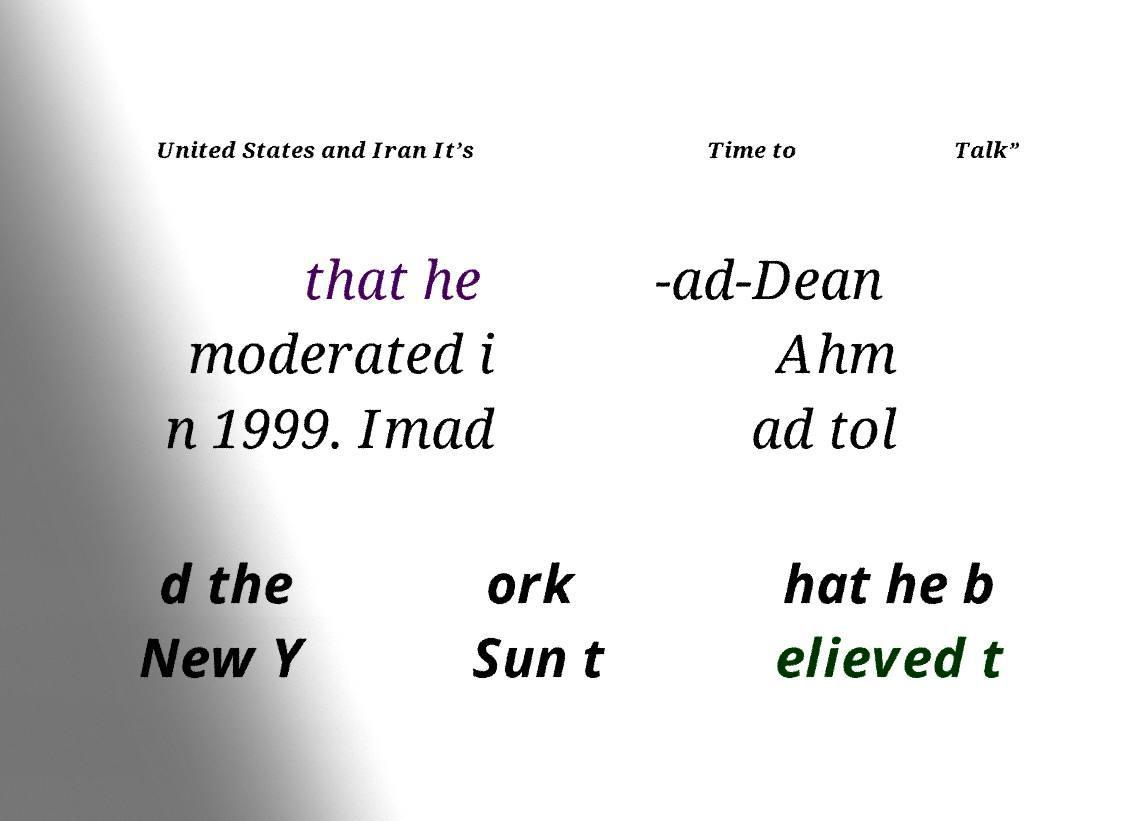Could you extract and type out the text from this image? United States and Iran It’s Time to Talk” that he moderated i n 1999. Imad -ad-Dean Ahm ad tol d the New Y ork Sun t hat he b elieved t 